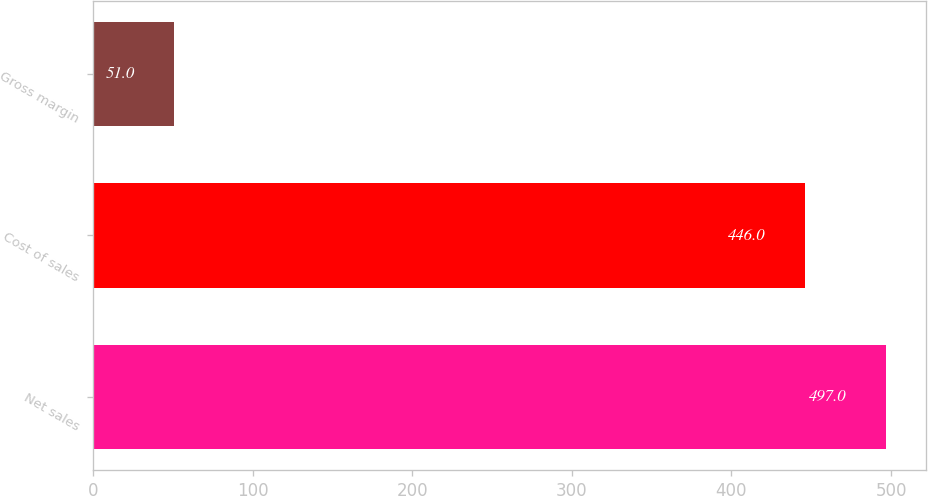Convert chart to OTSL. <chart><loc_0><loc_0><loc_500><loc_500><bar_chart><fcel>Net sales<fcel>Cost of sales<fcel>Gross margin<nl><fcel>497<fcel>446<fcel>51<nl></chart> 